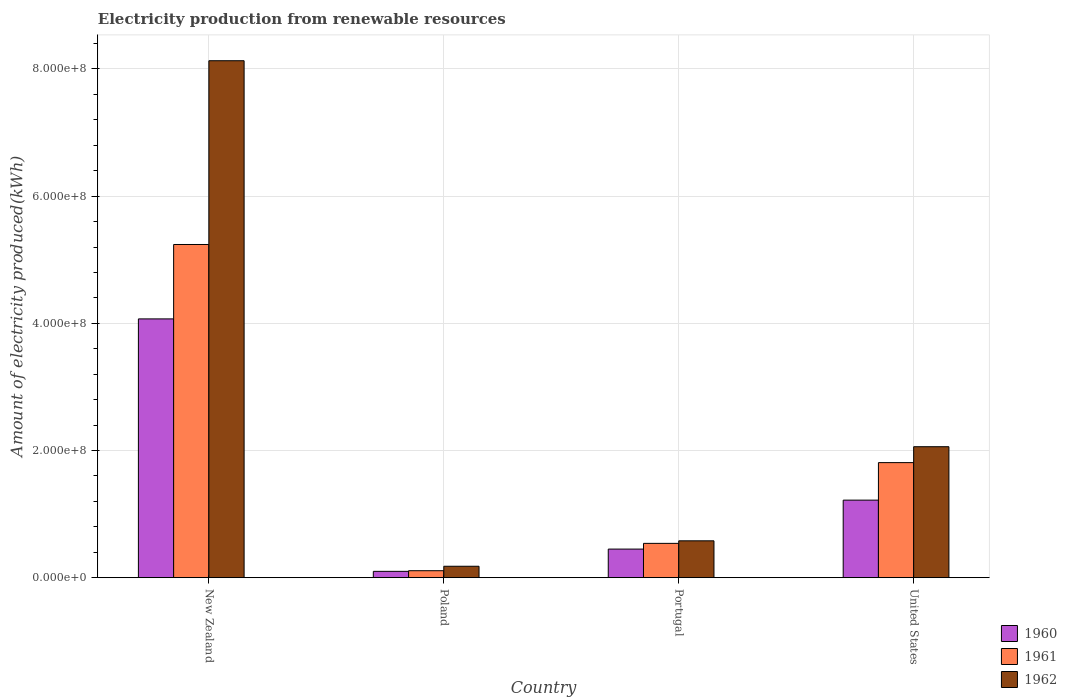Are the number of bars per tick equal to the number of legend labels?
Keep it short and to the point. Yes. Are the number of bars on each tick of the X-axis equal?
Your answer should be very brief. Yes. What is the amount of electricity produced in 1961 in Poland?
Provide a succinct answer. 1.10e+07. Across all countries, what is the maximum amount of electricity produced in 1961?
Provide a succinct answer. 5.24e+08. Across all countries, what is the minimum amount of electricity produced in 1962?
Make the answer very short. 1.80e+07. In which country was the amount of electricity produced in 1962 maximum?
Your answer should be very brief. New Zealand. What is the total amount of electricity produced in 1962 in the graph?
Provide a short and direct response. 1.10e+09. What is the difference between the amount of electricity produced in 1962 in New Zealand and that in Portugal?
Offer a terse response. 7.55e+08. What is the difference between the amount of electricity produced in 1962 in Portugal and the amount of electricity produced in 1961 in United States?
Make the answer very short. -1.23e+08. What is the average amount of electricity produced in 1961 per country?
Your response must be concise. 1.92e+08. What is the difference between the amount of electricity produced of/in 1960 and amount of electricity produced of/in 1962 in United States?
Ensure brevity in your answer.  -8.40e+07. What is the ratio of the amount of electricity produced in 1960 in New Zealand to that in Portugal?
Ensure brevity in your answer.  9.04. What is the difference between the highest and the second highest amount of electricity produced in 1960?
Offer a terse response. 3.62e+08. What is the difference between the highest and the lowest amount of electricity produced in 1962?
Ensure brevity in your answer.  7.95e+08. Is the sum of the amount of electricity produced in 1961 in Poland and United States greater than the maximum amount of electricity produced in 1962 across all countries?
Give a very brief answer. No. What does the 1st bar from the right in Portugal represents?
Provide a succinct answer. 1962. Is it the case that in every country, the sum of the amount of electricity produced in 1961 and amount of electricity produced in 1962 is greater than the amount of electricity produced in 1960?
Offer a terse response. Yes. Are the values on the major ticks of Y-axis written in scientific E-notation?
Give a very brief answer. Yes. Where does the legend appear in the graph?
Make the answer very short. Bottom right. How many legend labels are there?
Offer a terse response. 3. What is the title of the graph?
Provide a short and direct response. Electricity production from renewable resources. Does "1985" appear as one of the legend labels in the graph?
Give a very brief answer. No. What is the label or title of the X-axis?
Keep it short and to the point. Country. What is the label or title of the Y-axis?
Your response must be concise. Amount of electricity produced(kWh). What is the Amount of electricity produced(kWh) of 1960 in New Zealand?
Provide a succinct answer. 4.07e+08. What is the Amount of electricity produced(kWh) of 1961 in New Zealand?
Your answer should be very brief. 5.24e+08. What is the Amount of electricity produced(kWh) in 1962 in New Zealand?
Offer a very short reply. 8.13e+08. What is the Amount of electricity produced(kWh) of 1961 in Poland?
Provide a succinct answer. 1.10e+07. What is the Amount of electricity produced(kWh) of 1962 in Poland?
Provide a short and direct response. 1.80e+07. What is the Amount of electricity produced(kWh) in 1960 in Portugal?
Give a very brief answer. 4.50e+07. What is the Amount of electricity produced(kWh) in 1961 in Portugal?
Offer a very short reply. 5.40e+07. What is the Amount of electricity produced(kWh) of 1962 in Portugal?
Your response must be concise. 5.80e+07. What is the Amount of electricity produced(kWh) of 1960 in United States?
Offer a terse response. 1.22e+08. What is the Amount of electricity produced(kWh) in 1961 in United States?
Provide a succinct answer. 1.81e+08. What is the Amount of electricity produced(kWh) in 1962 in United States?
Provide a succinct answer. 2.06e+08. Across all countries, what is the maximum Amount of electricity produced(kWh) in 1960?
Give a very brief answer. 4.07e+08. Across all countries, what is the maximum Amount of electricity produced(kWh) in 1961?
Your answer should be compact. 5.24e+08. Across all countries, what is the maximum Amount of electricity produced(kWh) in 1962?
Provide a short and direct response. 8.13e+08. Across all countries, what is the minimum Amount of electricity produced(kWh) in 1960?
Make the answer very short. 1.00e+07. Across all countries, what is the minimum Amount of electricity produced(kWh) of 1961?
Your answer should be very brief. 1.10e+07. Across all countries, what is the minimum Amount of electricity produced(kWh) in 1962?
Give a very brief answer. 1.80e+07. What is the total Amount of electricity produced(kWh) in 1960 in the graph?
Make the answer very short. 5.84e+08. What is the total Amount of electricity produced(kWh) of 1961 in the graph?
Make the answer very short. 7.70e+08. What is the total Amount of electricity produced(kWh) of 1962 in the graph?
Offer a terse response. 1.10e+09. What is the difference between the Amount of electricity produced(kWh) in 1960 in New Zealand and that in Poland?
Your response must be concise. 3.97e+08. What is the difference between the Amount of electricity produced(kWh) in 1961 in New Zealand and that in Poland?
Give a very brief answer. 5.13e+08. What is the difference between the Amount of electricity produced(kWh) of 1962 in New Zealand and that in Poland?
Keep it short and to the point. 7.95e+08. What is the difference between the Amount of electricity produced(kWh) of 1960 in New Zealand and that in Portugal?
Provide a succinct answer. 3.62e+08. What is the difference between the Amount of electricity produced(kWh) in 1961 in New Zealand and that in Portugal?
Offer a very short reply. 4.70e+08. What is the difference between the Amount of electricity produced(kWh) in 1962 in New Zealand and that in Portugal?
Offer a very short reply. 7.55e+08. What is the difference between the Amount of electricity produced(kWh) in 1960 in New Zealand and that in United States?
Provide a succinct answer. 2.85e+08. What is the difference between the Amount of electricity produced(kWh) of 1961 in New Zealand and that in United States?
Give a very brief answer. 3.43e+08. What is the difference between the Amount of electricity produced(kWh) of 1962 in New Zealand and that in United States?
Your answer should be compact. 6.07e+08. What is the difference between the Amount of electricity produced(kWh) of 1960 in Poland and that in Portugal?
Your answer should be compact. -3.50e+07. What is the difference between the Amount of electricity produced(kWh) of 1961 in Poland and that in Portugal?
Your answer should be very brief. -4.30e+07. What is the difference between the Amount of electricity produced(kWh) of 1962 in Poland and that in Portugal?
Offer a very short reply. -4.00e+07. What is the difference between the Amount of electricity produced(kWh) of 1960 in Poland and that in United States?
Provide a succinct answer. -1.12e+08. What is the difference between the Amount of electricity produced(kWh) in 1961 in Poland and that in United States?
Make the answer very short. -1.70e+08. What is the difference between the Amount of electricity produced(kWh) of 1962 in Poland and that in United States?
Provide a short and direct response. -1.88e+08. What is the difference between the Amount of electricity produced(kWh) in 1960 in Portugal and that in United States?
Provide a succinct answer. -7.70e+07. What is the difference between the Amount of electricity produced(kWh) of 1961 in Portugal and that in United States?
Ensure brevity in your answer.  -1.27e+08. What is the difference between the Amount of electricity produced(kWh) of 1962 in Portugal and that in United States?
Provide a succinct answer. -1.48e+08. What is the difference between the Amount of electricity produced(kWh) in 1960 in New Zealand and the Amount of electricity produced(kWh) in 1961 in Poland?
Provide a succinct answer. 3.96e+08. What is the difference between the Amount of electricity produced(kWh) of 1960 in New Zealand and the Amount of electricity produced(kWh) of 1962 in Poland?
Your answer should be very brief. 3.89e+08. What is the difference between the Amount of electricity produced(kWh) in 1961 in New Zealand and the Amount of electricity produced(kWh) in 1962 in Poland?
Keep it short and to the point. 5.06e+08. What is the difference between the Amount of electricity produced(kWh) of 1960 in New Zealand and the Amount of electricity produced(kWh) of 1961 in Portugal?
Provide a succinct answer. 3.53e+08. What is the difference between the Amount of electricity produced(kWh) of 1960 in New Zealand and the Amount of electricity produced(kWh) of 1962 in Portugal?
Keep it short and to the point. 3.49e+08. What is the difference between the Amount of electricity produced(kWh) of 1961 in New Zealand and the Amount of electricity produced(kWh) of 1962 in Portugal?
Provide a succinct answer. 4.66e+08. What is the difference between the Amount of electricity produced(kWh) of 1960 in New Zealand and the Amount of electricity produced(kWh) of 1961 in United States?
Give a very brief answer. 2.26e+08. What is the difference between the Amount of electricity produced(kWh) in 1960 in New Zealand and the Amount of electricity produced(kWh) in 1962 in United States?
Provide a succinct answer. 2.01e+08. What is the difference between the Amount of electricity produced(kWh) in 1961 in New Zealand and the Amount of electricity produced(kWh) in 1962 in United States?
Ensure brevity in your answer.  3.18e+08. What is the difference between the Amount of electricity produced(kWh) in 1960 in Poland and the Amount of electricity produced(kWh) in 1961 in Portugal?
Offer a very short reply. -4.40e+07. What is the difference between the Amount of electricity produced(kWh) of 1960 in Poland and the Amount of electricity produced(kWh) of 1962 in Portugal?
Provide a short and direct response. -4.80e+07. What is the difference between the Amount of electricity produced(kWh) of 1961 in Poland and the Amount of electricity produced(kWh) of 1962 in Portugal?
Your response must be concise. -4.70e+07. What is the difference between the Amount of electricity produced(kWh) of 1960 in Poland and the Amount of electricity produced(kWh) of 1961 in United States?
Give a very brief answer. -1.71e+08. What is the difference between the Amount of electricity produced(kWh) of 1960 in Poland and the Amount of electricity produced(kWh) of 1962 in United States?
Your answer should be very brief. -1.96e+08. What is the difference between the Amount of electricity produced(kWh) in 1961 in Poland and the Amount of electricity produced(kWh) in 1962 in United States?
Provide a short and direct response. -1.95e+08. What is the difference between the Amount of electricity produced(kWh) in 1960 in Portugal and the Amount of electricity produced(kWh) in 1961 in United States?
Your answer should be compact. -1.36e+08. What is the difference between the Amount of electricity produced(kWh) of 1960 in Portugal and the Amount of electricity produced(kWh) of 1962 in United States?
Provide a short and direct response. -1.61e+08. What is the difference between the Amount of electricity produced(kWh) in 1961 in Portugal and the Amount of electricity produced(kWh) in 1962 in United States?
Give a very brief answer. -1.52e+08. What is the average Amount of electricity produced(kWh) in 1960 per country?
Offer a terse response. 1.46e+08. What is the average Amount of electricity produced(kWh) in 1961 per country?
Make the answer very short. 1.92e+08. What is the average Amount of electricity produced(kWh) in 1962 per country?
Make the answer very short. 2.74e+08. What is the difference between the Amount of electricity produced(kWh) of 1960 and Amount of electricity produced(kWh) of 1961 in New Zealand?
Offer a very short reply. -1.17e+08. What is the difference between the Amount of electricity produced(kWh) of 1960 and Amount of electricity produced(kWh) of 1962 in New Zealand?
Provide a succinct answer. -4.06e+08. What is the difference between the Amount of electricity produced(kWh) in 1961 and Amount of electricity produced(kWh) in 1962 in New Zealand?
Make the answer very short. -2.89e+08. What is the difference between the Amount of electricity produced(kWh) of 1960 and Amount of electricity produced(kWh) of 1961 in Poland?
Ensure brevity in your answer.  -1.00e+06. What is the difference between the Amount of electricity produced(kWh) of 1960 and Amount of electricity produced(kWh) of 1962 in Poland?
Offer a terse response. -8.00e+06. What is the difference between the Amount of electricity produced(kWh) in 1961 and Amount of electricity produced(kWh) in 1962 in Poland?
Keep it short and to the point. -7.00e+06. What is the difference between the Amount of electricity produced(kWh) in 1960 and Amount of electricity produced(kWh) in 1961 in Portugal?
Give a very brief answer. -9.00e+06. What is the difference between the Amount of electricity produced(kWh) in 1960 and Amount of electricity produced(kWh) in 1962 in Portugal?
Ensure brevity in your answer.  -1.30e+07. What is the difference between the Amount of electricity produced(kWh) of 1960 and Amount of electricity produced(kWh) of 1961 in United States?
Provide a short and direct response. -5.90e+07. What is the difference between the Amount of electricity produced(kWh) in 1960 and Amount of electricity produced(kWh) in 1962 in United States?
Provide a short and direct response. -8.40e+07. What is the difference between the Amount of electricity produced(kWh) in 1961 and Amount of electricity produced(kWh) in 1962 in United States?
Your answer should be compact. -2.50e+07. What is the ratio of the Amount of electricity produced(kWh) in 1960 in New Zealand to that in Poland?
Your answer should be compact. 40.7. What is the ratio of the Amount of electricity produced(kWh) in 1961 in New Zealand to that in Poland?
Your answer should be very brief. 47.64. What is the ratio of the Amount of electricity produced(kWh) in 1962 in New Zealand to that in Poland?
Your response must be concise. 45.17. What is the ratio of the Amount of electricity produced(kWh) of 1960 in New Zealand to that in Portugal?
Make the answer very short. 9.04. What is the ratio of the Amount of electricity produced(kWh) in 1961 in New Zealand to that in Portugal?
Give a very brief answer. 9.7. What is the ratio of the Amount of electricity produced(kWh) in 1962 in New Zealand to that in Portugal?
Provide a short and direct response. 14.02. What is the ratio of the Amount of electricity produced(kWh) in 1960 in New Zealand to that in United States?
Ensure brevity in your answer.  3.34. What is the ratio of the Amount of electricity produced(kWh) of 1961 in New Zealand to that in United States?
Your answer should be very brief. 2.9. What is the ratio of the Amount of electricity produced(kWh) in 1962 in New Zealand to that in United States?
Ensure brevity in your answer.  3.95. What is the ratio of the Amount of electricity produced(kWh) in 1960 in Poland to that in Portugal?
Your answer should be very brief. 0.22. What is the ratio of the Amount of electricity produced(kWh) of 1961 in Poland to that in Portugal?
Provide a short and direct response. 0.2. What is the ratio of the Amount of electricity produced(kWh) of 1962 in Poland to that in Portugal?
Provide a short and direct response. 0.31. What is the ratio of the Amount of electricity produced(kWh) of 1960 in Poland to that in United States?
Make the answer very short. 0.08. What is the ratio of the Amount of electricity produced(kWh) of 1961 in Poland to that in United States?
Offer a very short reply. 0.06. What is the ratio of the Amount of electricity produced(kWh) in 1962 in Poland to that in United States?
Offer a terse response. 0.09. What is the ratio of the Amount of electricity produced(kWh) in 1960 in Portugal to that in United States?
Your response must be concise. 0.37. What is the ratio of the Amount of electricity produced(kWh) in 1961 in Portugal to that in United States?
Ensure brevity in your answer.  0.3. What is the ratio of the Amount of electricity produced(kWh) of 1962 in Portugal to that in United States?
Your answer should be compact. 0.28. What is the difference between the highest and the second highest Amount of electricity produced(kWh) of 1960?
Your response must be concise. 2.85e+08. What is the difference between the highest and the second highest Amount of electricity produced(kWh) of 1961?
Keep it short and to the point. 3.43e+08. What is the difference between the highest and the second highest Amount of electricity produced(kWh) in 1962?
Provide a succinct answer. 6.07e+08. What is the difference between the highest and the lowest Amount of electricity produced(kWh) of 1960?
Provide a succinct answer. 3.97e+08. What is the difference between the highest and the lowest Amount of electricity produced(kWh) in 1961?
Your response must be concise. 5.13e+08. What is the difference between the highest and the lowest Amount of electricity produced(kWh) of 1962?
Keep it short and to the point. 7.95e+08. 